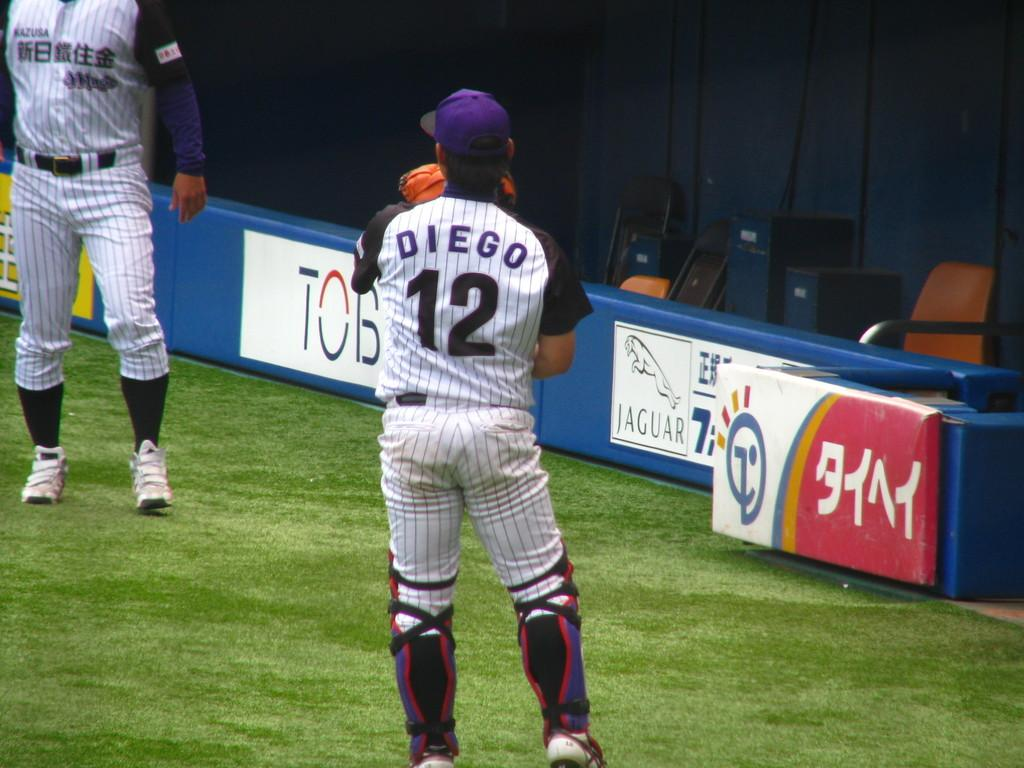<image>
Write a terse but informative summary of the picture. A baseball player with his back to the camera has DIEGO #12 on his jersey. 